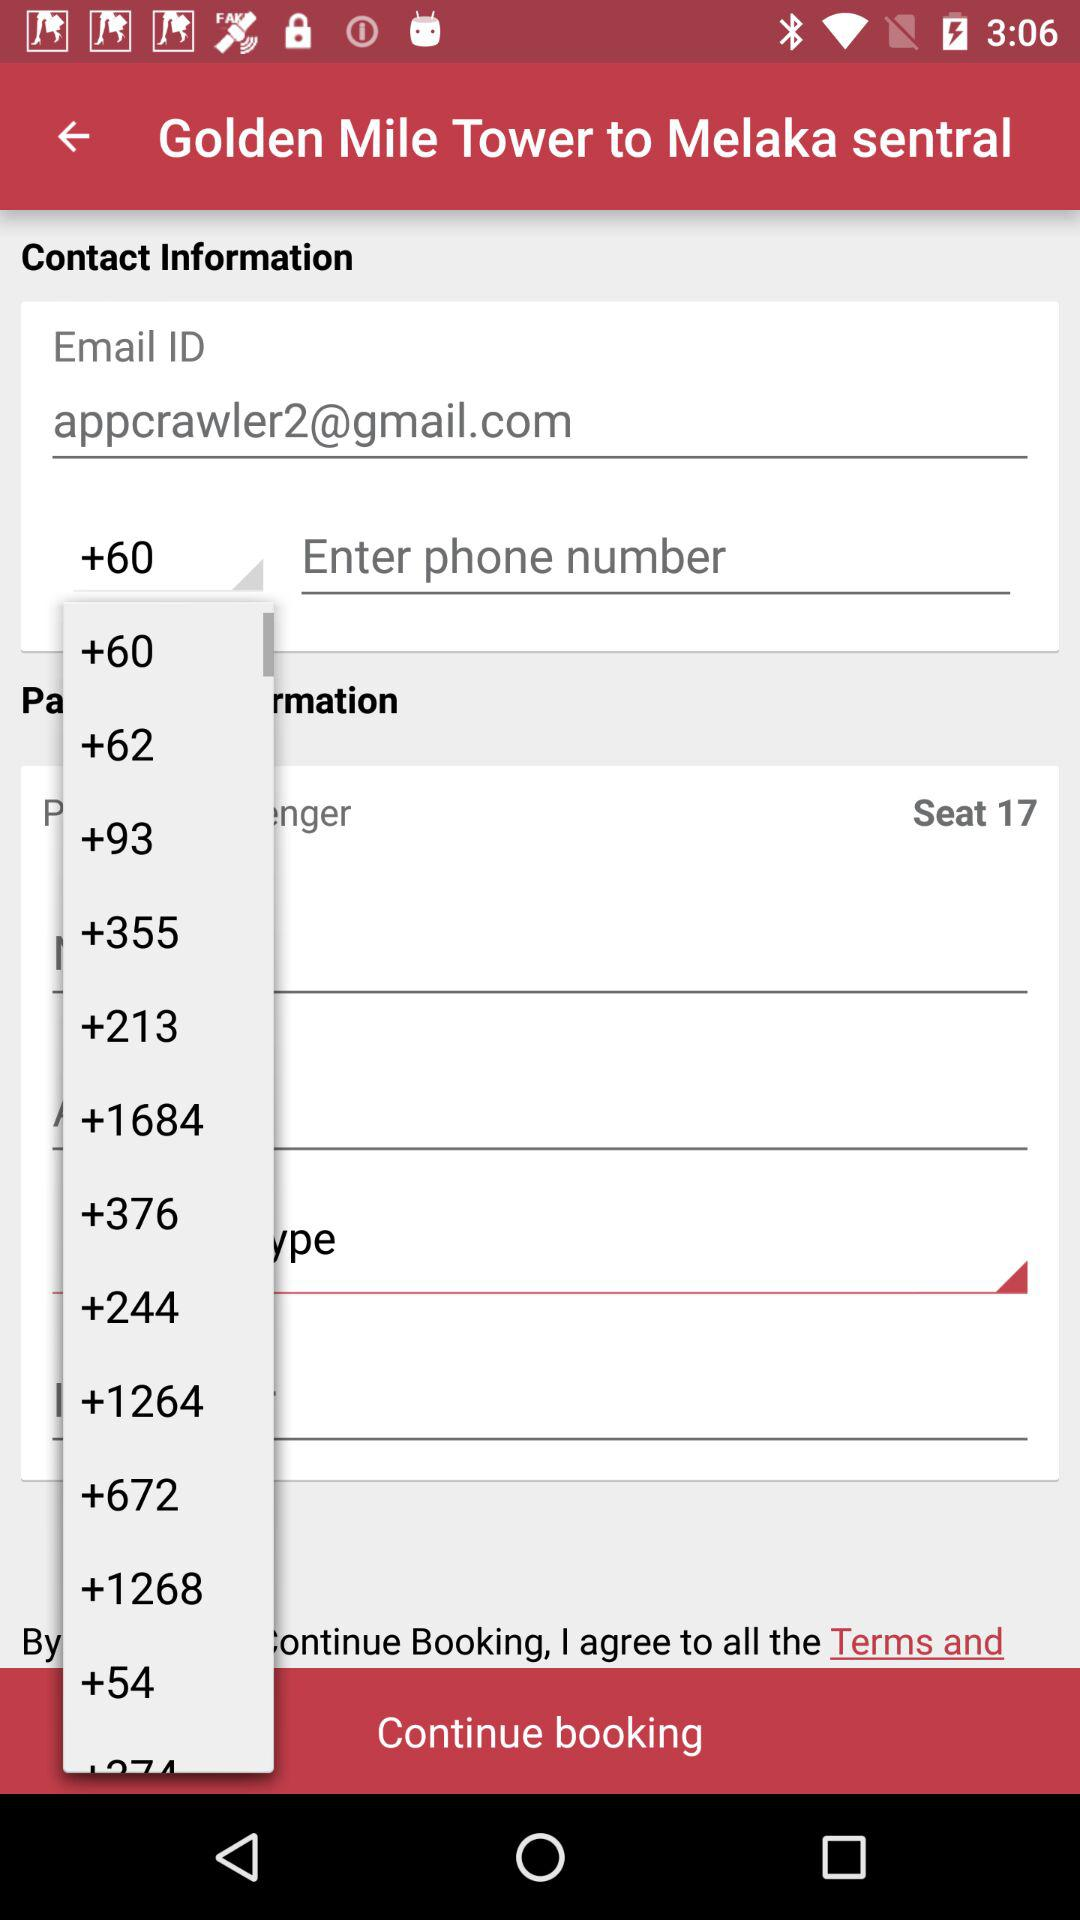What is the email address? The email address is appcrawler2@gmail.com. 